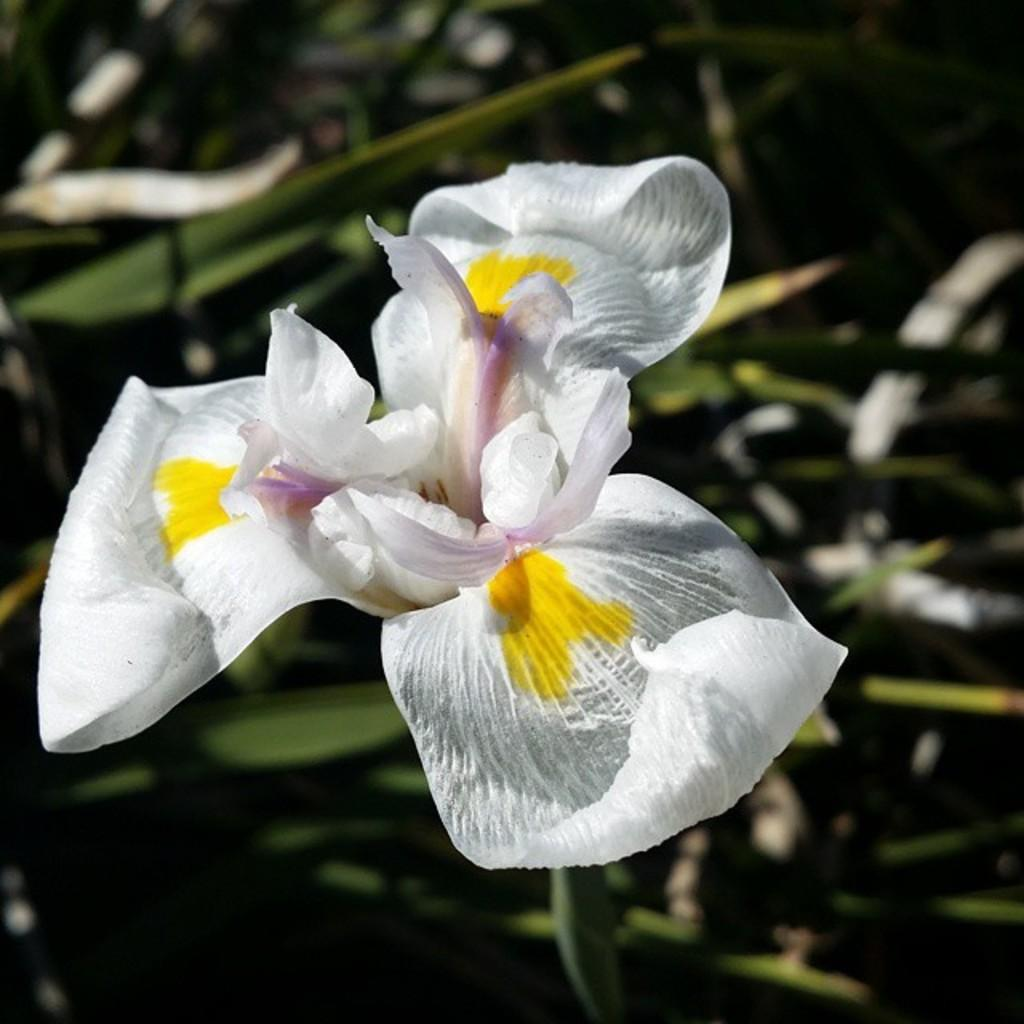What is the main subject of the image? The main subject of the image is a flower. Can you describe the flower's location in the image? The flower is on the stem of a plant. What does the brother do with the crib in the image? There is no brother or crib present in the image; it only features a flower on the stem of a plant. 